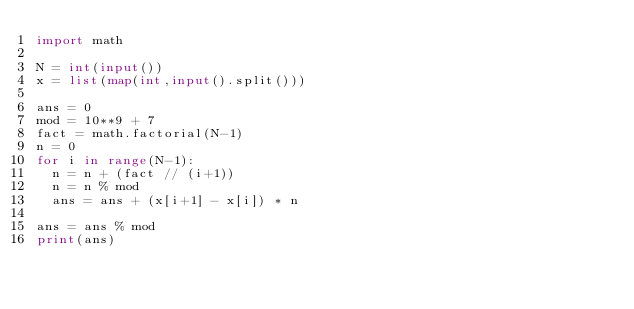<code> <loc_0><loc_0><loc_500><loc_500><_Python_>import math

N = int(input())
x = list(map(int,input().split()))
  
ans = 0
mod = 10**9 + 7
fact = math.factorial(N-1)
n = 0
for i in range(N-1):
  n = n + (fact // (i+1))
  n = n % mod
  ans = ans + (x[i+1] - x[i]) * n

ans = ans % mod
print(ans)</code> 